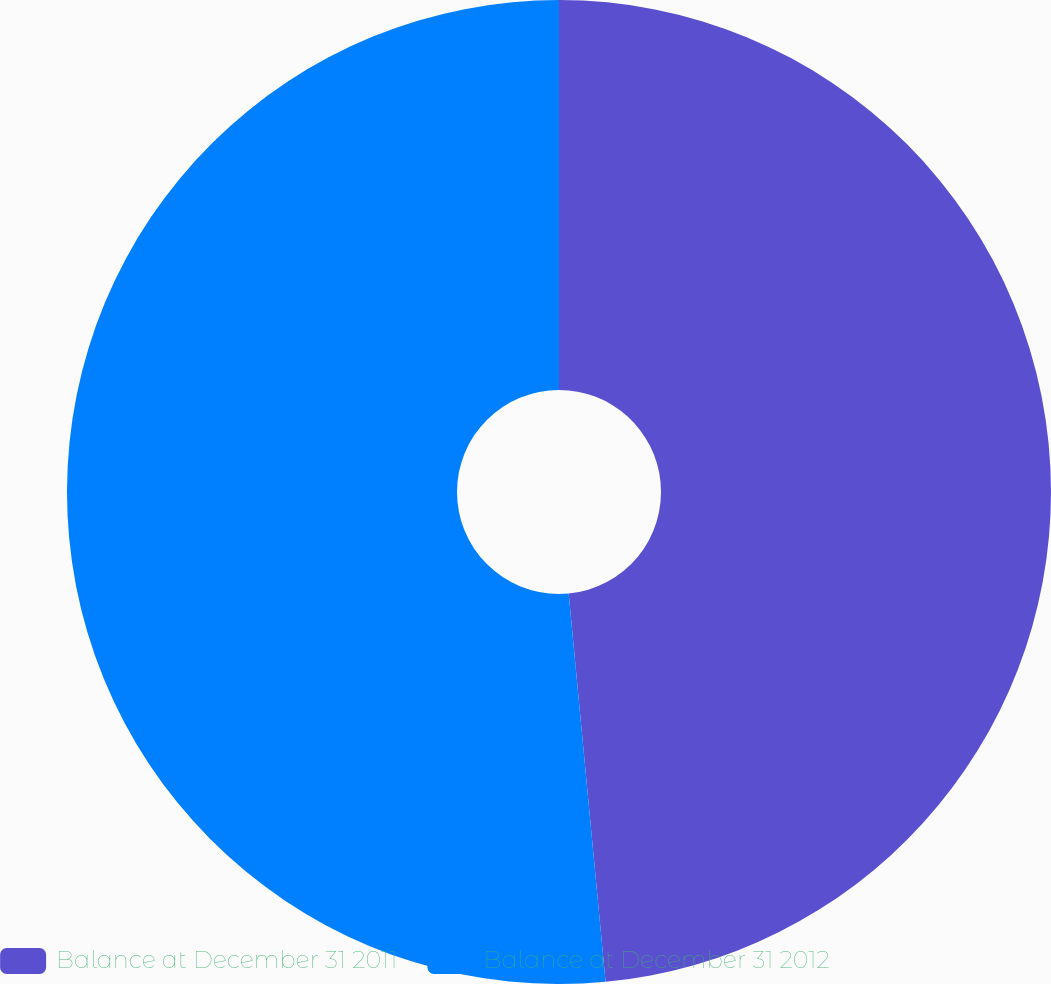Convert chart to OTSL. <chart><loc_0><loc_0><loc_500><loc_500><pie_chart><fcel>Balance at December 31 2011<fcel>Balance at December 31 2012<nl><fcel>48.49%<fcel>51.51%<nl></chart> 